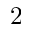Convert formula to latex. <formula><loc_0><loc_0><loc_500><loc_500>2</formula> 